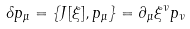<formula> <loc_0><loc_0><loc_500><loc_500>\delta p _ { \mu } = \{ J [ \xi ] , p _ { \mu } \} = \partial _ { \mu } \xi ^ { \nu } p _ { \nu }</formula> 